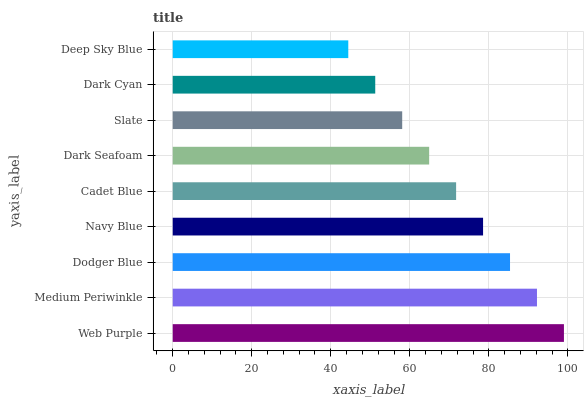Is Deep Sky Blue the minimum?
Answer yes or no. Yes. Is Web Purple the maximum?
Answer yes or no. Yes. Is Medium Periwinkle the minimum?
Answer yes or no. No. Is Medium Periwinkle the maximum?
Answer yes or no. No. Is Web Purple greater than Medium Periwinkle?
Answer yes or no. Yes. Is Medium Periwinkle less than Web Purple?
Answer yes or no. Yes. Is Medium Periwinkle greater than Web Purple?
Answer yes or no. No. Is Web Purple less than Medium Periwinkle?
Answer yes or no. No. Is Cadet Blue the high median?
Answer yes or no. Yes. Is Cadet Blue the low median?
Answer yes or no. Yes. Is Web Purple the high median?
Answer yes or no. No. Is Deep Sky Blue the low median?
Answer yes or no. No. 